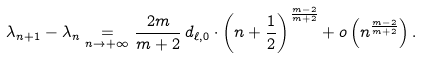<formula> <loc_0><loc_0><loc_500><loc_500>\lambda _ { n + 1 } - \lambda _ { n } \underset { n \to + \infty } { = } \frac { 2 m } { m + 2 } \, d _ { \ell , 0 } \cdot \left ( n + \frac { 1 } { 2 } \right ) ^ { \frac { m - 2 } { m + 2 } } + o \left ( n ^ { \frac { m - 2 } { m + 2 } } \right ) .</formula> 